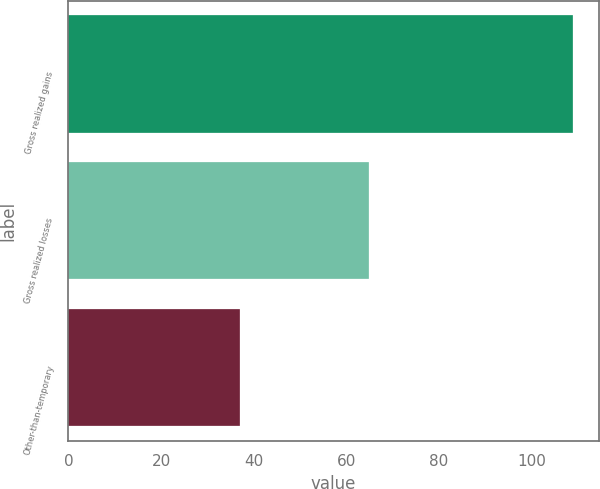Convert chart to OTSL. <chart><loc_0><loc_0><loc_500><loc_500><bar_chart><fcel>Gross realized gains<fcel>Gross realized losses<fcel>Other-than-temporary<nl><fcel>109<fcel>65<fcel>37<nl></chart> 